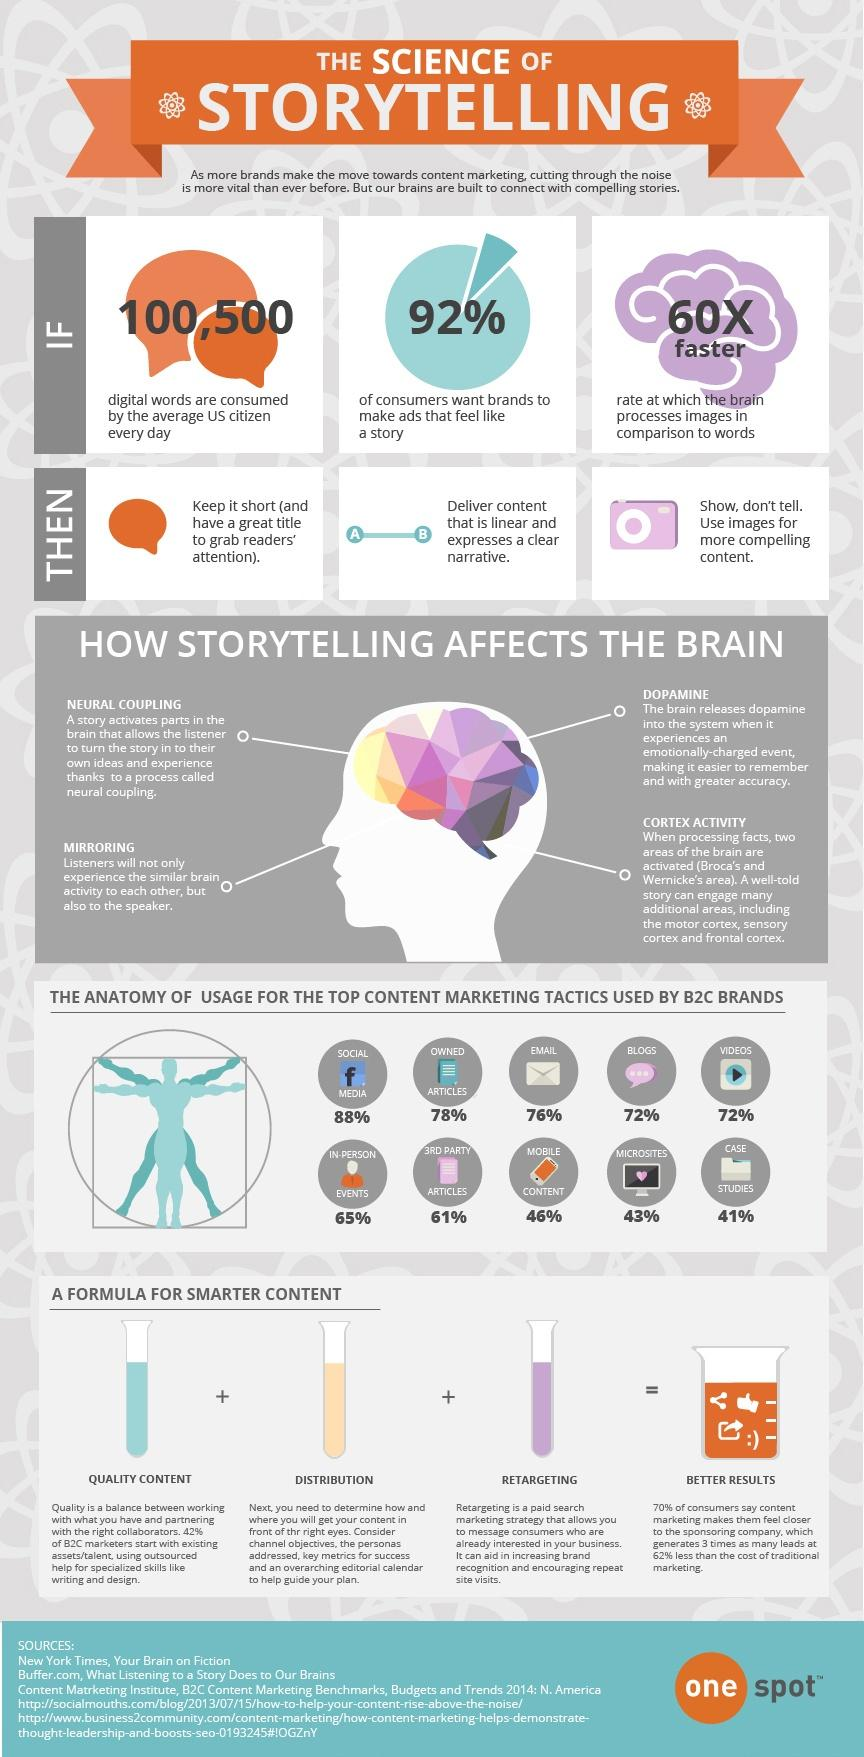Indicate a few pertinent items in this graphic. The least used content marketing tactic by B2C brands is case studies. For smarter content creation, quality content, effective distribution, and retargeting are essential formula ingredients. According to a survey, 76% of B2C brands in the U.S. use various email marketing tactics. Approximately 46% of B2C brands in the United States utilize mobile content marketing tactics. Approximately 72% of B2C brands in the United States use video marketing tactics. 